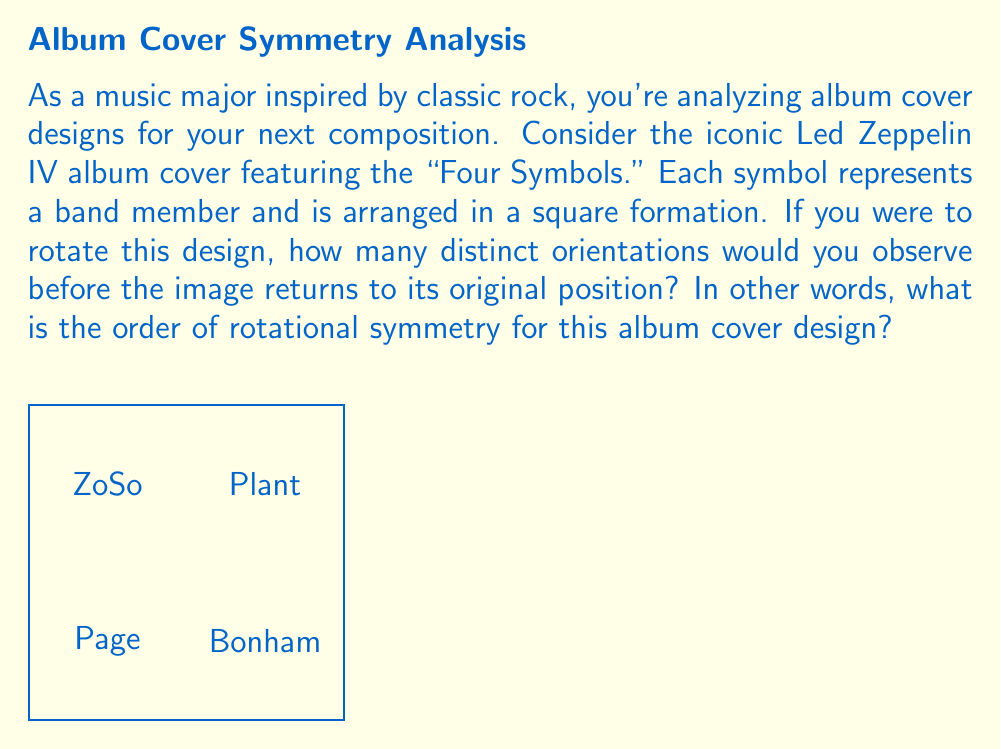Could you help me with this problem? To determine the order of rotational symmetry, we need to consider how many unique rotations the design can undergo before returning to its original position. Let's approach this step-by-step:

1) First, we need to understand what rotational symmetry means. An object has rotational symmetry if it looks the same after a certain amount of rotation.

2) In this case, we have four symbols arranged in a square formation. Each symbol represents a different band member, so they are distinct from each other.

3) Let's consider the possible rotations:
   - 0° rotation (original position)
   - 90° rotation clockwise
   - 180° rotation
   - 270° rotation clockwise (or 90° counterclockwise)

4) After a 360° rotation, we return to the original position.

5) Each of these rotations (0°, 90°, 180°, 270°) produces a distinct arrangement of the symbols.

6) The number of distinct orientations before returning to the original position is 4.

7) In group theory terms, this means the design has a rotational symmetry group isomorphic to the cyclic group $C_4$.

8) The order of a cyclic group is equal to the number of elements in the group, which in this case is 4.

Therefore, the order of rotational symmetry for this album cover design is 4.
Answer: 4 